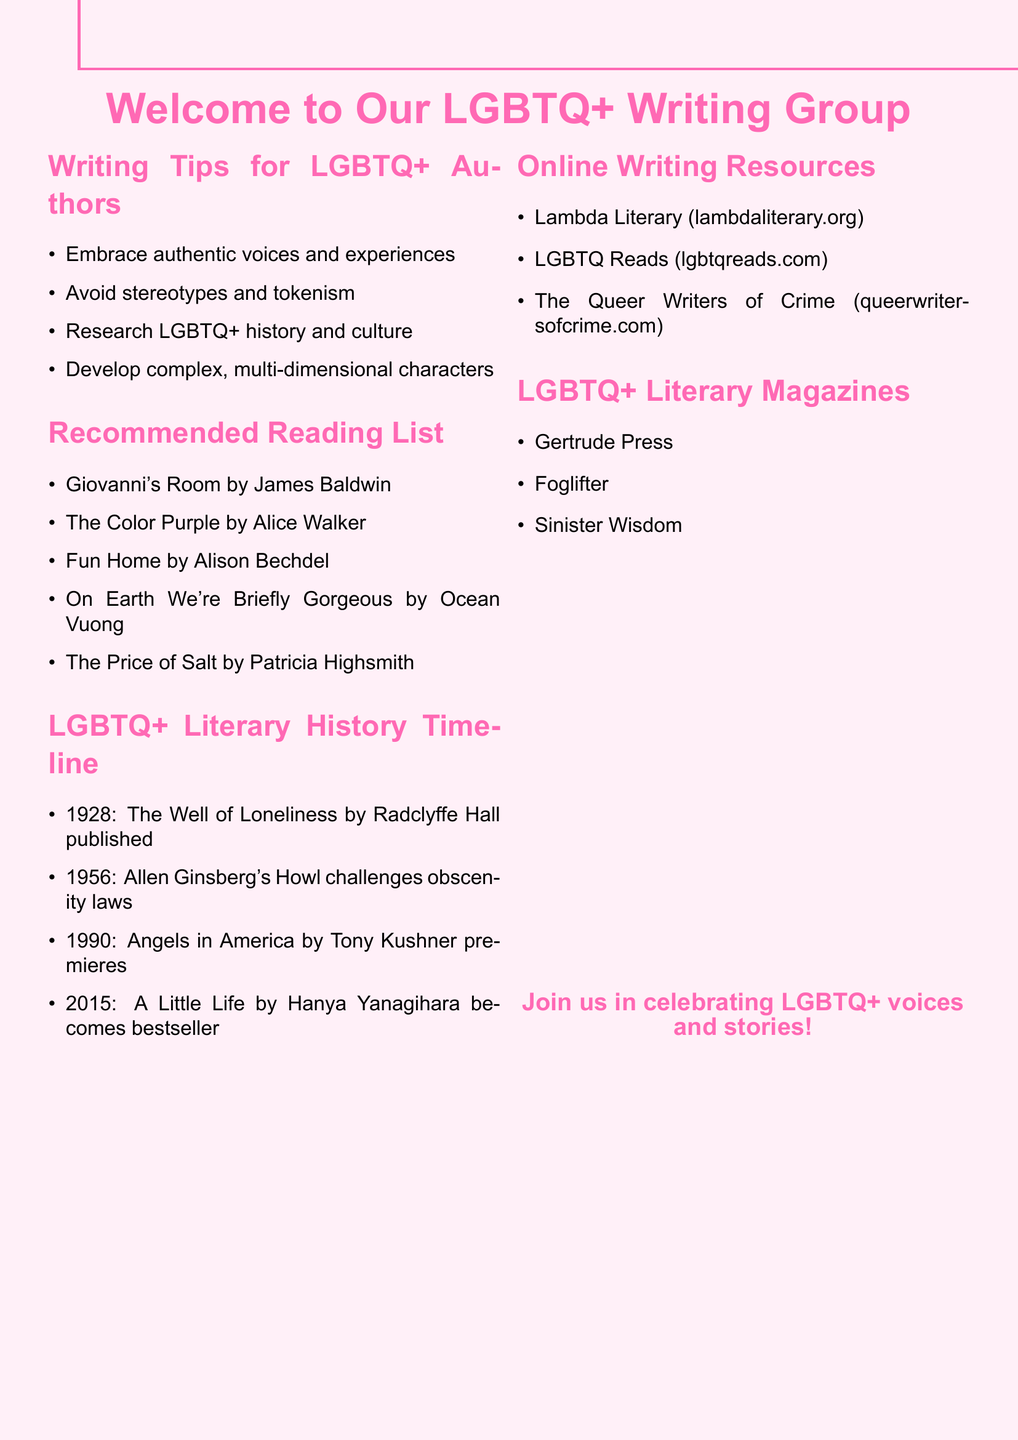What is the title of the writing tips section? The title of the writing tips section is clearly stated at the beginning of that part of the document.
Answer: Writing Tips for LGBTQ+ Authors How many books are listed in the recommended reading list? The number of books can be counted by looking at the items in the recommended reading section.
Answer: 5 What year was "The Well of Loneliness" published? The year of publication is specified in the timeline of LGBTQ+ literary history.
Answer: 1928 Which magazine is mentioned in the LGBTQ+ literary magazines section? The document lists specific magazines under this heading.
Answer: Gertrude Press What is one website included in the online writing resources? An example can be found in the list of web resources provided in the document.
Answer: Lambda Literary What is emphasized as essential for character development in the writing tips? The writing tips section offers specific advice on character development.
Answer: Complex, multi-dimensional characters Which author wrote "On Earth We're Briefly Gorgeous"? The name of the author can be identified from the list of recommended readings.
Answer: Ocean Vuong In what year did "Angels in America" premiere? The year of the premiere is documented in the LGBTQ+ literary history timeline.
Answer: 1990 How many literary magazines are mentioned? The total number can be determined from the list provided under the literary magazines section.
Answer: 3 